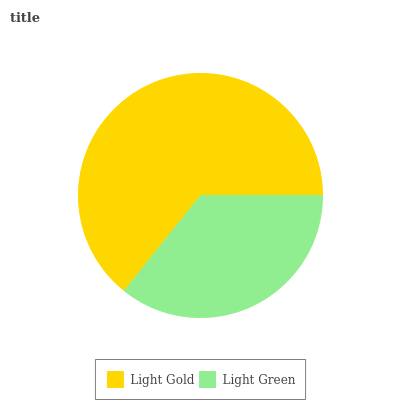Is Light Green the minimum?
Answer yes or no. Yes. Is Light Gold the maximum?
Answer yes or no. Yes. Is Light Green the maximum?
Answer yes or no. No. Is Light Gold greater than Light Green?
Answer yes or no. Yes. Is Light Green less than Light Gold?
Answer yes or no. Yes. Is Light Green greater than Light Gold?
Answer yes or no. No. Is Light Gold less than Light Green?
Answer yes or no. No. Is Light Gold the high median?
Answer yes or no. Yes. Is Light Green the low median?
Answer yes or no. Yes. Is Light Green the high median?
Answer yes or no. No. Is Light Gold the low median?
Answer yes or no. No. 